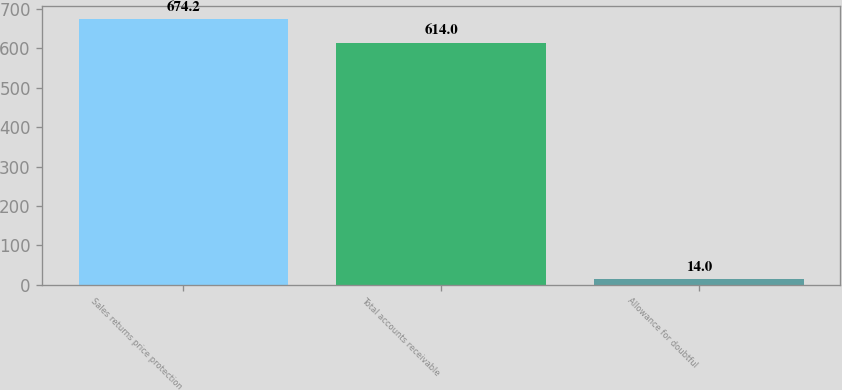Convert chart to OTSL. <chart><loc_0><loc_0><loc_500><loc_500><bar_chart><fcel>Sales returns price protection<fcel>Total accounts receivable<fcel>Allowance for doubtful<nl><fcel>674.2<fcel>614<fcel>14<nl></chart> 